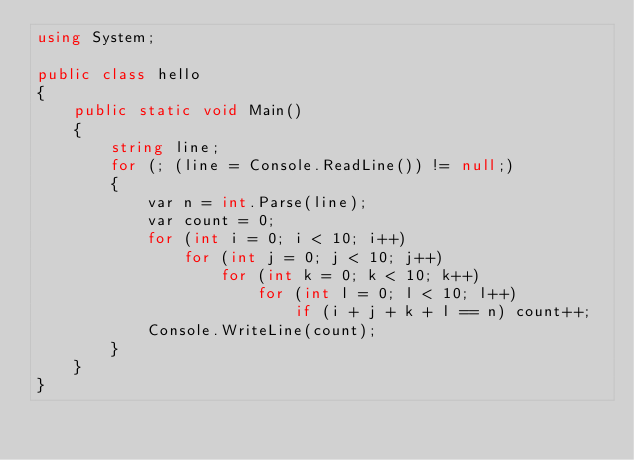<code> <loc_0><loc_0><loc_500><loc_500><_C#_>using System;

public class hello
{
    public static void Main()
    {
        string line;
        for (; (line = Console.ReadLine()) != null;)
        {
            var n = int.Parse(line);
            var count = 0;
            for (int i = 0; i < 10; i++)
                for (int j = 0; j < 10; j++)
                    for (int k = 0; k < 10; k++)
                        for (int l = 0; l < 10; l++)
                            if (i + j + k + l == n) count++;
            Console.WriteLine(count);
        }
    }
}</code> 